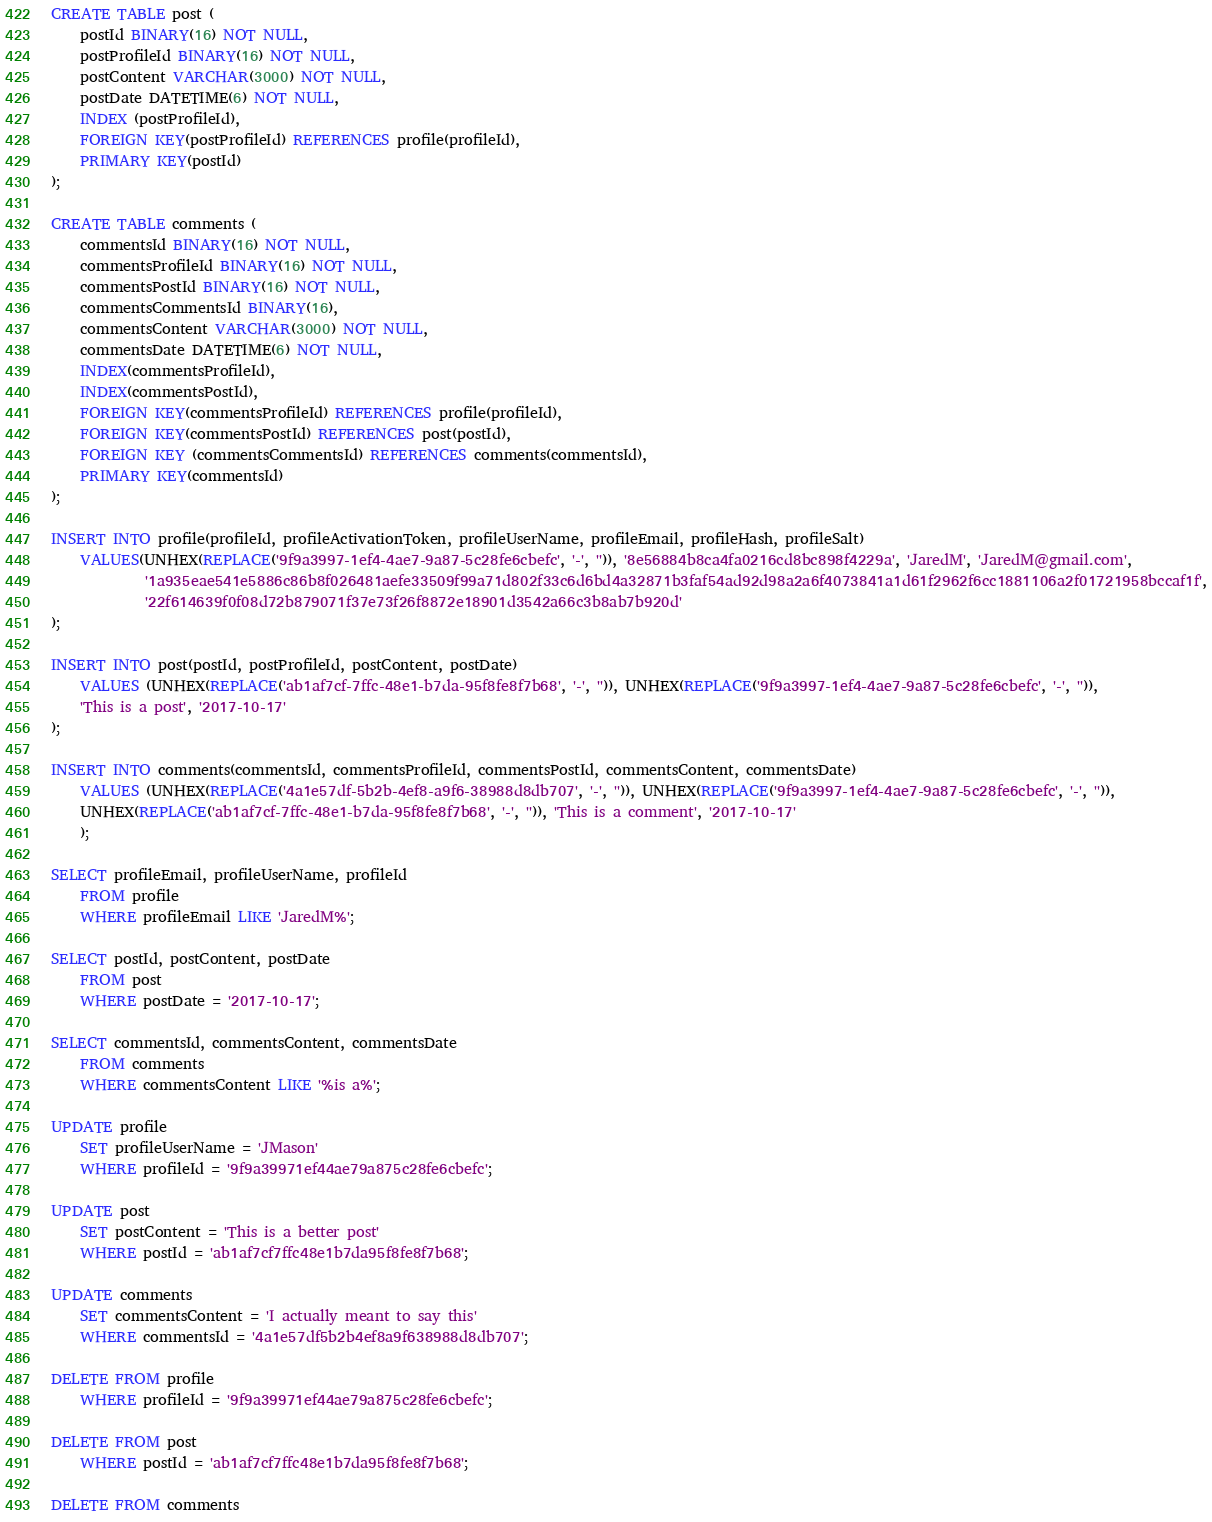Convert code to text. <code><loc_0><loc_0><loc_500><loc_500><_SQL_>
CREATE TABLE post (
	postId BINARY(16) NOT NULL,
	postProfileId BINARY(16) NOT NULL,
	postContent VARCHAR(3000) NOT NULL,
	postDate DATETIME(6) NOT NULL,
	INDEX (postProfileId),
	FOREIGN KEY(postProfileId) REFERENCES profile(profileId),
	PRIMARY KEY(postId)
);

CREATE TABLE comments (
	commentsId BINARY(16) NOT NULL,
	commentsProfileId BINARY(16) NOT NULL,
	commentsPostId BINARY(16) NOT NULL,
	commentsCommentsId BINARY(16),
	commentsContent VARCHAR(3000) NOT NULL,
	commentsDate DATETIME(6) NOT NULL,
	INDEX(commentsProfileId),
	INDEX(commentsPostId),
	FOREIGN KEY(commentsProfileId) REFERENCES profile(profileId),
	FOREIGN KEY(commentsPostId) REFERENCES post(postId),
	FOREIGN KEY (commentsCommentsId) REFERENCES comments(commentsId),
	PRIMARY KEY(commentsId)
);

INSERT INTO profile(profileId, profileActivationToken, profileUserName, profileEmail, profileHash, profileSalt)
	VALUES(UNHEX(REPLACE('9f9a3997-1ef4-4ae7-9a87-5c28fe6cbefc', '-', '')), '8e56884b8ca4fa0216cd8bc898f4229a', 'JaredM', 'JaredM@gmail.com',
			 '1a935eae541e5886c86b8f026481aefe33509f99a71d802f33c6d6bd4a32871b3faf54ad92d98a2a6f4073841a1d61f2962f6cc1881106a2f01721958bccaf1f',
			 '22f614639f0f08d72b879071f37e73f26f8872e18901d3542a66c3b8ab7b920d'
);

INSERT INTO post(postId, postProfileId, postContent, postDate)
	VALUES (UNHEX(REPLACE('ab1af7cf-7ffc-48e1-b7da-95f8fe8f7b68', '-', '')), UNHEX(REPLACE('9f9a3997-1ef4-4ae7-9a87-5c28fe6cbefc', '-', '')),
	'This is a post', '2017-10-17'
);

INSERT INTO comments(commentsId, commentsProfileId, commentsPostId, commentsContent, commentsDate)
	VALUES (UNHEX(REPLACE('4a1e57df-5b2b-4ef8-a9f6-38988d8db707', '-', '')), UNHEX(REPLACE('9f9a3997-1ef4-4ae7-9a87-5c28fe6cbefc', '-', '')),
	UNHEX(REPLACE('ab1af7cf-7ffc-48e1-b7da-95f8fe8f7b68', '-', '')), 'This is a comment', '2017-10-17'
	);

SELECT profileEmail, profileUserName, profileId
	FROM profile
	WHERE profileEmail LIKE 'JaredM%';

SELECT postId, postContent, postDate
	FROM post
	WHERE postDate = '2017-10-17';

SELECT commentsId, commentsContent, commentsDate
	FROM comments
	WHERE commentsContent LIKE '%is a%';

UPDATE profile
	SET profileUserName = 'JMason'
	WHERE profileId = '9f9a39971ef44ae79a875c28fe6cbefc';

UPDATE post
	SET postContent = 'This is a better post'
	WHERE postId = 'ab1af7cf7ffc48e1b7da95f8fe8f7b68';

UPDATE comments
	SET commentsContent = 'I actually meant to say this'
	WHERE commentsId = '4a1e57df5b2b4ef8a9f638988d8db707';

DELETE FROM profile
	WHERE profileId = '9f9a39971ef44ae79a875c28fe6cbefc';

DELETE FROM post
	WHERE postId = 'ab1af7cf7ffc48e1b7da95f8fe8f7b68';

DELETE FROM comments</code> 